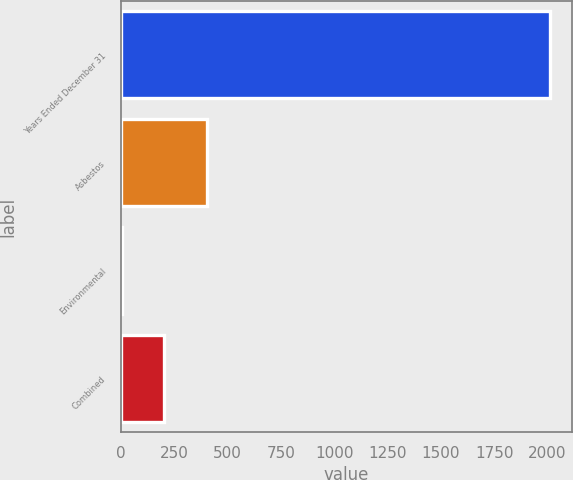Convert chart to OTSL. <chart><loc_0><loc_0><loc_500><loc_500><bar_chart><fcel>Years Ended December 31<fcel>Asbestos<fcel>Environmental<fcel>Combined<nl><fcel>2013<fcel>405.72<fcel>3.9<fcel>204.81<nl></chart> 